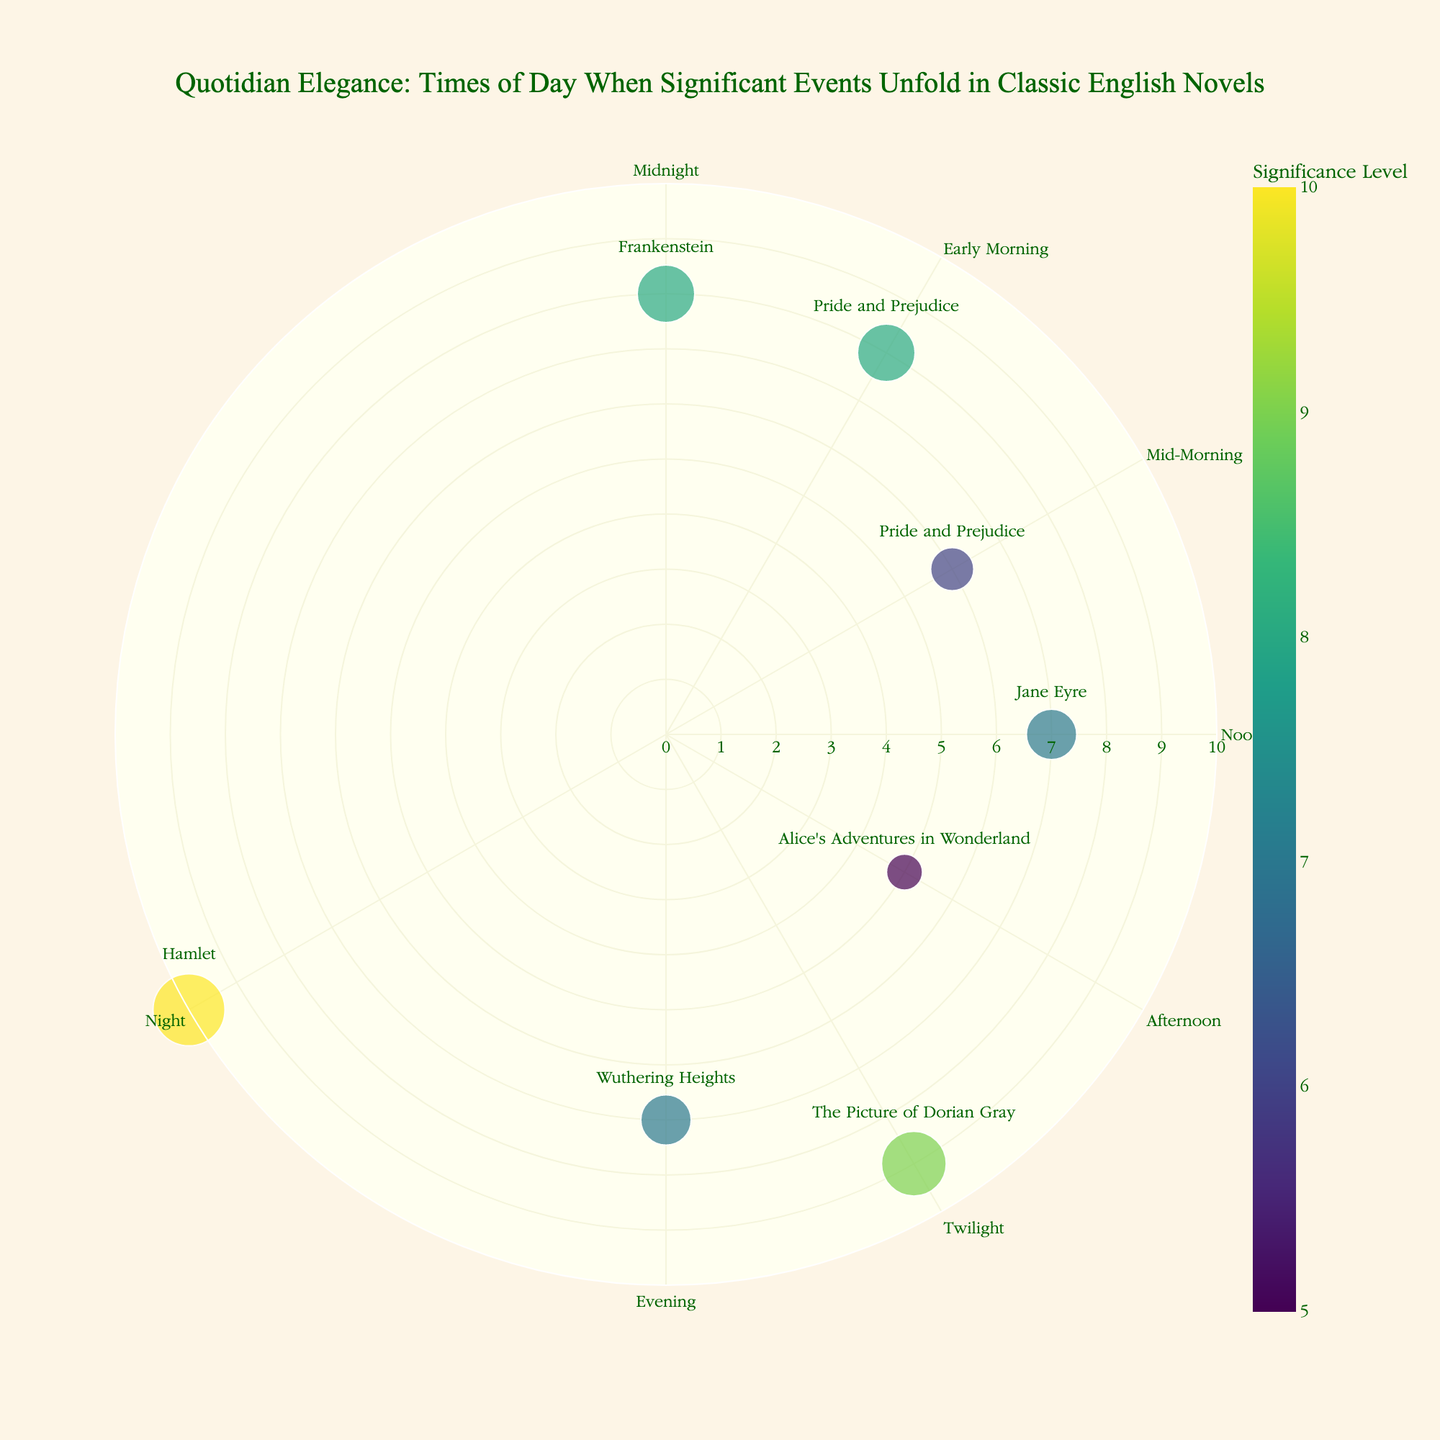what is the title of the plot? The title is clearly displayed at the top of the plot in a decorative font. It states: "Quotidian Elegance: Times of Day When Significant Events Unfold in Classic English Novels"
Answer: Quotidian Elegance: Times of Day When Significant Events Unfold in Classic English Novels what is the time period associated with the highest significance level of 10? The plot shows markers corresponding to the significance levels at various angles representing times of the day. The highest significance level of 10 is positioned at the angle representing "Night"
Answer: Night how many significant events occurred during the daytime (Morning, Mid-Morning, Noon, and Afternoon)? The daytime period includes Early Morning, Mid-Morning, Noon, and Afternoon. Examining the markers and their labels shows that there are four events with given significance levels during these periods: Mr. Darcy's First Proposal, Elizabeth Bennet's Encounter with Lady Catherine, Jane Eyre Rescues Mr. Rochester, and Alice Meets the Cheshire Cat
Answer: 4 which time of day has the lowest significance level, and what event does it correspond to? By observing the radial distance of all markers, the smallest value is 5, which is placed at 120°, corresponding to "Afternoon". The event associated with this time is Alice Meeting the Cheshire Cat from "Alice's Adventures in Wonderland"
Answer: Afternoon, Alice Meets the Cheshire Cat compare the significance levels of events that happened in "Pride and Prejudice". Which one has a higher value? "Pride and Prejudice" appears twice on the plot related to two events. Mr. Darcy's First Proposal has a significance level of 8, while Elizabeth Bennet's Encounter with Lady Catherine has a significance level of 6. Therefore, Mr. Darcy's First Proposal has a higher value
Answer: Mr. Darcy's First Proposal how many novels have a significance level of 7, and can you name them? Searching for markers with a radial distance of 7, we identify two events: "Jane Eyre" which corresponds to rescuing Mr. Rochester, and "Wuthering Heights" which involves Catherine Earnshaw's return
Answer: 2, Jane Eyre and Wuthering Heights which novel's event has the unique time slot of "Twilight" and what is the significance level of this event? "Twilight" has only one marker placed at its angle. The corresponding event is "Dorian Gray's Pact with Youth" from "The Picture of Dorian Gray," with a significance value of 9
Answer: The Picture of Dorian Gray, 9 identify the event aligned with "Midnight" and describe its significance level. "Midnight" is directly labeled on the plot's circular axis with a corresponding event marker. The event is Dr. Frankenstein Animating the Creature from "Frankenstein," with a significance level of 8
Answer: Dr. Frankenstein Animates the Creature, 8 